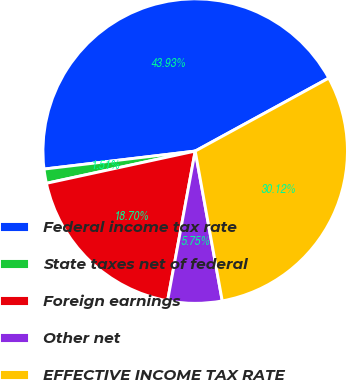Convert chart. <chart><loc_0><loc_0><loc_500><loc_500><pie_chart><fcel>Federal income tax rate<fcel>State taxes net of federal<fcel>Foreign earnings<fcel>Other net<fcel>EFFECTIVE INCOME TAX RATE<nl><fcel>43.93%<fcel>1.51%<fcel>18.7%<fcel>5.75%<fcel>30.12%<nl></chart> 